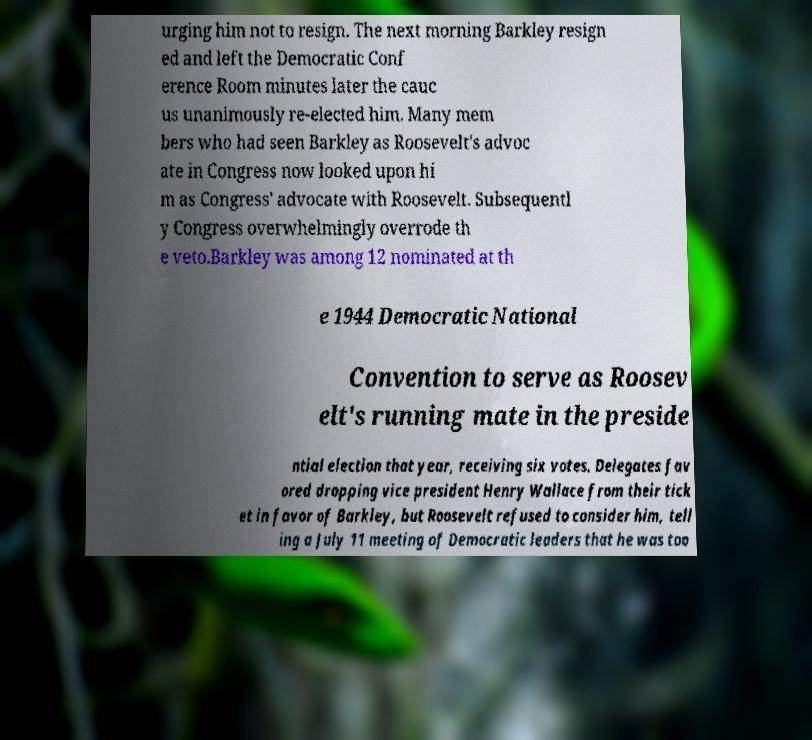Please read and relay the text visible in this image. What does it say? urging him not to resign. The next morning Barkley resign ed and left the Democratic Conf erence Room minutes later the cauc us unanimously re-elected him. Many mem bers who had seen Barkley as Roosevelt's advoc ate in Congress now looked upon hi m as Congress' advocate with Roosevelt. Subsequentl y Congress overwhelmingly overrode th e veto.Barkley was among 12 nominated at th e 1944 Democratic National Convention to serve as Roosev elt's running mate in the preside ntial election that year, receiving six votes. Delegates fav ored dropping vice president Henry Wallace from their tick et in favor of Barkley, but Roosevelt refused to consider him, tell ing a July 11 meeting of Democratic leaders that he was too 